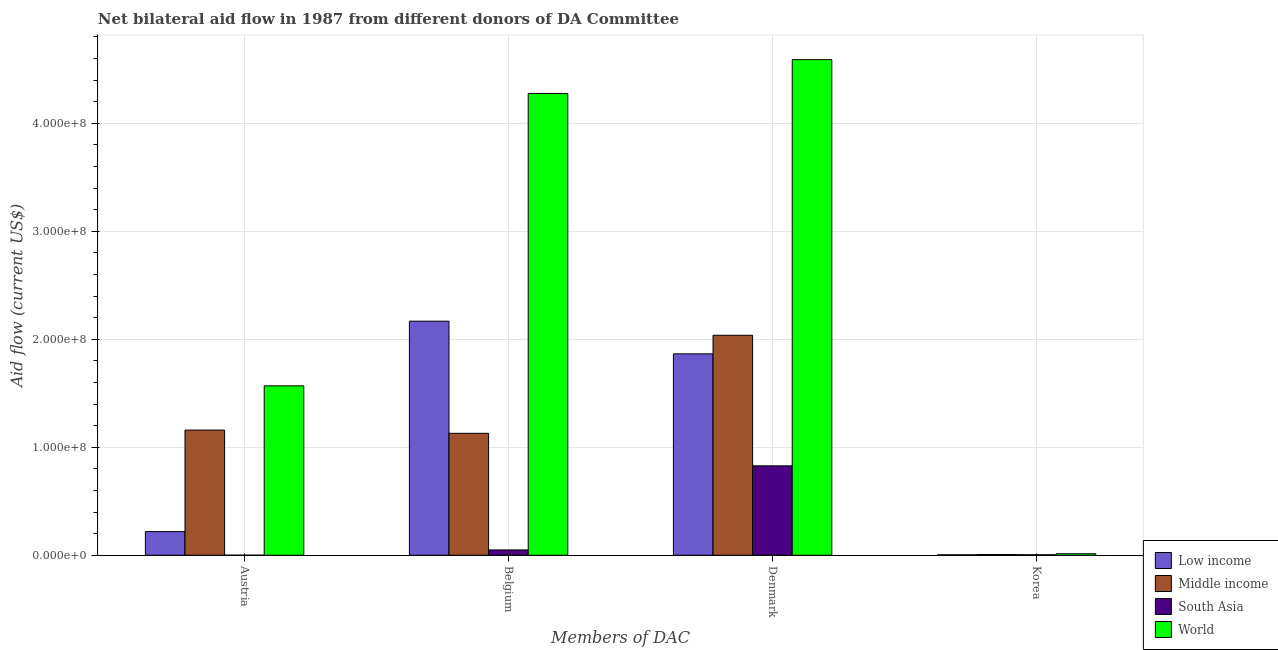How many different coloured bars are there?
Keep it short and to the point. 4. What is the label of the 4th group of bars from the left?
Keep it short and to the point. Korea. What is the amount of aid given by austria in World?
Give a very brief answer. 1.57e+08. Across all countries, what is the maximum amount of aid given by belgium?
Give a very brief answer. 4.28e+08. Across all countries, what is the minimum amount of aid given by austria?
Provide a succinct answer. 6.00e+04. In which country was the amount of aid given by korea maximum?
Keep it short and to the point. World. In which country was the amount of aid given by belgium minimum?
Provide a short and direct response. South Asia. What is the total amount of aid given by korea in the graph?
Ensure brevity in your answer.  2.94e+06. What is the difference between the amount of aid given by denmark in Middle income and that in World?
Your answer should be compact. -2.55e+08. What is the difference between the amount of aid given by korea in South Asia and the amount of aid given by belgium in Middle income?
Provide a succinct answer. -1.12e+08. What is the average amount of aid given by austria per country?
Keep it short and to the point. 7.37e+07. What is the difference between the amount of aid given by belgium and amount of aid given by austria in South Asia?
Your response must be concise. 4.87e+06. In how many countries, is the amount of aid given by korea greater than 380000000 US$?
Your answer should be compact. 0. What is the ratio of the amount of aid given by korea in Low income to that in World?
Offer a very short reply. 0.29. Is the amount of aid given by korea in Middle income less than that in South Asia?
Make the answer very short. No. Is the difference between the amount of aid given by belgium in Middle income and Low income greater than the difference between the amount of aid given by denmark in Middle income and Low income?
Ensure brevity in your answer.  No. What is the difference between the highest and the second highest amount of aid given by austria?
Offer a terse response. 4.10e+07. What is the difference between the highest and the lowest amount of aid given by belgium?
Offer a terse response. 4.23e+08. Is the sum of the amount of aid given by korea in Low income and South Asia greater than the maximum amount of aid given by denmark across all countries?
Make the answer very short. No. Is it the case that in every country, the sum of the amount of aid given by belgium and amount of aid given by korea is greater than the sum of amount of aid given by austria and amount of aid given by denmark?
Your response must be concise. No. Is it the case that in every country, the sum of the amount of aid given by austria and amount of aid given by belgium is greater than the amount of aid given by denmark?
Provide a short and direct response. No. Are all the bars in the graph horizontal?
Offer a very short reply. No. What is the difference between two consecutive major ticks on the Y-axis?
Offer a terse response. 1.00e+08. Does the graph contain any zero values?
Your answer should be compact. No. Does the graph contain grids?
Keep it short and to the point. Yes. How many legend labels are there?
Give a very brief answer. 4. What is the title of the graph?
Your response must be concise. Net bilateral aid flow in 1987 from different donors of DA Committee. What is the label or title of the X-axis?
Offer a terse response. Members of DAC. What is the Aid flow (current US$) of Low income in Austria?
Provide a succinct answer. 2.19e+07. What is the Aid flow (current US$) of Middle income in Austria?
Give a very brief answer. 1.16e+08. What is the Aid flow (current US$) of South Asia in Austria?
Keep it short and to the point. 6.00e+04. What is the Aid flow (current US$) of World in Austria?
Provide a succinct answer. 1.57e+08. What is the Aid flow (current US$) of Low income in Belgium?
Offer a very short reply. 2.17e+08. What is the Aid flow (current US$) of Middle income in Belgium?
Your answer should be very brief. 1.13e+08. What is the Aid flow (current US$) of South Asia in Belgium?
Make the answer very short. 4.93e+06. What is the Aid flow (current US$) in World in Belgium?
Your answer should be compact. 4.28e+08. What is the Aid flow (current US$) of Low income in Denmark?
Your answer should be very brief. 1.87e+08. What is the Aid flow (current US$) in Middle income in Denmark?
Your answer should be compact. 2.04e+08. What is the Aid flow (current US$) of South Asia in Denmark?
Provide a succinct answer. 8.28e+07. What is the Aid flow (current US$) in World in Denmark?
Make the answer very short. 4.59e+08. What is the Aid flow (current US$) of Middle income in Korea?
Offer a terse response. 6.70e+05. What is the Aid flow (current US$) of World in Korea?
Give a very brief answer. 1.40e+06. Across all Members of DAC, what is the maximum Aid flow (current US$) of Low income?
Offer a very short reply. 2.17e+08. Across all Members of DAC, what is the maximum Aid flow (current US$) of Middle income?
Your answer should be very brief. 2.04e+08. Across all Members of DAC, what is the maximum Aid flow (current US$) of South Asia?
Provide a succinct answer. 8.28e+07. Across all Members of DAC, what is the maximum Aid flow (current US$) of World?
Ensure brevity in your answer.  4.59e+08. Across all Members of DAC, what is the minimum Aid flow (current US$) in Low income?
Ensure brevity in your answer.  4.10e+05. Across all Members of DAC, what is the minimum Aid flow (current US$) in Middle income?
Ensure brevity in your answer.  6.70e+05. Across all Members of DAC, what is the minimum Aid flow (current US$) of South Asia?
Offer a terse response. 6.00e+04. Across all Members of DAC, what is the minimum Aid flow (current US$) in World?
Your response must be concise. 1.40e+06. What is the total Aid flow (current US$) in Low income in the graph?
Provide a succinct answer. 4.26e+08. What is the total Aid flow (current US$) in Middle income in the graph?
Provide a succinct answer. 4.33e+08. What is the total Aid flow (current US$) in South Asia in the graph?
Your response must be concise. 8.83e+07. What is the total Aid flow (current US$) of World in the graph?
Your answer should be compact. 1.05e+09. What is the difference between the Aid flow (current US$) in Low income in Austria and that in Belgium?
Offer a very short reply. -1.95e+08. What is the difference between the Aid flow (current US$) in Middle income in Austria and that in Belgium?
Keep it short and to the point. 3.01e+06. What is the difference between the Aid flow (current US$) in South Asia in Austria and that in Belgium?
Keep it short and to the point. -4.87e+06. What is the difference between the Aid flow (current US$) in World in Austria and that in Belgium?
Keep it short and to the point. -2.71e+08. What is the difference between the Aid flow (current US$) in Low income in Austria and that in Denmark?
Offer a terse response. -1.65e+08. What is the difference between the Aid flow (current US$) of Middle income in Austria and that in Denmark?
Offer a very short reply. -8.78e+07. What is the difference between the Aid flow (current US$) of South Asia in Austria and that in Denmark?
Your response must be concise. -8.28e+07. What is the difference between the Aid flow (current US$) of World in Austria and that in Denmark?
Your answer should be very brief. -3.02e+08. What is the difference between the Aid flow (current US$) of Low income in Austria and that in Korea?
Provide a succinct answer. 2.15e+07. What is the difference between the Aid flow (current US$) of Middle income in Austria and that in Korea?
Offer a terse response. 1.15e+08. What is the difference between the Aid flow (current US$) in South Asia in Austria and that in Korea?
Provide a short and direct response. -4.00e+05. What is the difference between the Aid flow (current US$) in World in Austria and that in Korea?
Offer a terse response. 1.56e+08. What is the difference between the Aid flow (current US$) in Low income in Belgium and that in Denmark?
Offer a terse response. 3.02e+07. What is the difference between the Aid flow (current US$) of Middle income in Belgium and that in Denmark?
Make the answer very short. -9.08e+07. What is the difference between the Aid flow (current US$) in South Asia in Belgium and that in Denmark?
Provide a short and direct response. -7.79e+07. What is the difference between the Aid flow (current US$) in World in Belgium and that in Denmark?
Offer a very short reply. -3.13e+07. What is the difference between the Aid flow (current US$) of Low income in Belgium and that in Korea?
Keep it short and to the point. 2.16e+08. What is the difference between the Aid flow (current US$) in Middle income in Belgium and that in Korea?
Your answer should be compact. 1.12e+08. What is the difference between the Aid flow (current US$) of South Asia in Belgium and that in Korea?
Your answer should be very brief. 4.47e+06. What is the difference between the Aid flow (current US$) in World in Belgium and that in Korea?
Keep it short and to the point. 4.26e+08. What is the difference between the Aid flow (current US$) in Low income in Denmark and that in Korea?
Keep it short and to the point. 1.86e+08. What is the difference between the Aid flow (current US$) of Middle income in Denmark and that in Korea?
Provide a succinct answer. 2.03e+08. What is the difference between the Aid flow (current US$) in South Asia in Denmark and that in Korea?
Provide a short and direct response. 8.24e+07. What is the difference between the Aid flow (current US$) in World in Denmark and that in Korea?
Keep it short and to the point. 4.58e+08. What is the difference between the Aid flow (current US$) of Low income in Austria and the Aid flow (current US$) of Middle income in Belgium?
Offer a terse response. -9.10e+07. What is the difference between the Aid flow (current US$) of Low income in Austria and the Aid flow (current US$) of South Asia in Belgium?
Offer a terse response. 1.70e+07. What is the difference between the Aid flow (current US$) in Low income in Austria and the Aid flow (current US$) in World in Belgium?
Your response must be concise. -4.06e+08. What is the difference between the Aid flow (current US$) of Middle income in Austria and the Aid flow (current US$) of South Asia in Belgium?
Your answer should be very brief. 1.11e+08. What is the difference between the Aid flow (current US$) of Middle income in Austria and the Aid flow (current US$) of World in Belgium?
Keep it short and to the point. -3.12e+08. What is the difference between the Aid flow (current US$) of South Asia in Austria and the Aid flow (current US$) of World in Belgium?
Your answer should be compact. -4.28e+08. What is the difference between the Aid flow (current US$) of Low income in Austria and the Aid flow (current US$) of Middle income in Denmark?
Your answer should be very brief. -1.82e+08. What is the difference between the Aid flow (current US$) of Low income in Austria and the Aid flow (current US$) of South Asia in Denmark?
Give a very brief answer. -6.09e+07. What is the difference between the Aid flow (current US$) of Low income in Austria and the Aid flow (current US$) of World in Denmark?
Ensure brevity in your answer.  -4.37e+08. What is the difference between the Aid flow (current US$) in Middle income in Austria and the Aid flow (current US$) in South Asia in Denmark?
Provide a succinct answer. 3.31e+07. What is the difference between the Aid flow (current US$) of Middle income in Austria and the Aid flow (current US$) of World in Denmark?
Ensure brevity in your answer.  -3.43e+08. What is the difference between the Aid flow (current US$) of South Asia in Austria and the Aid flow (current US$) of World in Denmark?
Ensure brevity in your answer.  -4.59e+08. What is the difference between the Aid flow (current US$) in Low income in Austria and the Aid flow (current US$) in Middle income in Korea?
Ensure brevity in your answer.  2.12e+07. What is the difference between the Aid flow (current US$) of Low income in Austria and the Aid flow (current US$) of South Asia in Korea?
Provide a succinct answer. 2.14e+07. What is the difference between the Aid flow (current US$) in Low income in Austria and the Aid flow (current US$) in World in Korea?
Make the answer very short. 2.05e+07. What is the difference between the Aid flow (current US$) of Middle income in Austria and the Aid flow (current US$) of South Asia in Korea?
Provide a short and direct response. 1.15e+08. What is the difference between the Aid flow (current US$) in Middle income in Austria and the Aid flow (current US$) in World in Korea?
Offer a terse response. 1.15e+08. What is the difference between the Aid flow (current US$) of South Asia in Austria and the Aid flow (current US$) of World in Korea?
Your response must be concise. -1.34e+06. What is the difference between the Aid flow (current US$) of Low income in Belgium and the Aid flow (current US$) of Middle income in Denmark?
Offer a very short reply. 1.30e+07. What is the difference between the Aid flow (current US$) in Low income in Belgium and the Aid flow (current US$) in South Asia in Denmark?
Your answer should be compact. 1.34e+08. What is the difference between the Aid flow (current US$) in Low income in Belgium and the Aid flow (current US$) in World in Denmark?
Offer a terse response. -2.42e+08. What is the difference between the Aid flow (current US$) of Middle income in Belgium and the Aid flow (current US$) of South Asia in Denmark?
Make the answer very short. 3.01e+07. What is the difference between the Aid flow (current US$) of Middle income in Belgium and the Aid flow (current US$) of World in Denmark?
Give a very brief answer. -3.46e+08. What is the difference between the Aid flow (current US$) of South Asia in Belgium and the Aid flow (current US$) of World in Denmark?
Offer a terse response. -4.54e+08. What is the difference between the Aid flow (current US$) in Low income in Belgium and the Aid flow (current US$) in Middle income in Korea?
Offer a terse response. 2.16e+08. What is the difference between the Aid flow (current US$) of Low income in Belgium and the Aid flow (current US$) of South Asia in Korea?
Offer a terse response. 2.16e+08. What is the difference between the Aid flow (current US$) of Low income in Belgium and the Aid flow (current US$) of World in Korea?
Provide a short and direct response. 2.15e+08. What is the difference between the Aid flow (current US$) in Middle income in Belgium and the Aid flow (current US$) in South Asia in Korea?
Your response must be concise. 1.12e+08. What is the difference between the Aid flow (current US$) in Middle income in Belgium and the Aid flow (current US$) in World in Korea?
Your answer should be very brief. 1.12e+08. What is the difference between the Aid flow (current US$) of South Asia in Belgium and the Aid flow (current US$) of World in Korea?
Provide a succinct answer. 3.53e+06. What is the difference between the Aid flow (current US$) in Low income in Denmark and the Aid flow (current US$) in Middle income in Korea?
Provide a succinct answer. 1.86e+08. What is the difference between the Aid flow (current US$) in Low income in Denmark and the Aid flow (current US$) in South Asia in Korea?
Your response must be concise. 1.86e+08. What is the difference between the Aid flow (current US$) of Low income in Denmark and the Aid flow (current US$) of World in Korea?
Provide a short and direct response. 1.85e+08. What is the difference between the Aid flow (current US$) of Middle income in Denmark and the Aid flow (current US$) of South Asia in Korea?
Keep it short and to the point. 2.03e+08. What is the difference between the Aid flow (current US$) of Middle income in Denmark and the Aid flow (current US$) of World in Korea?
Make the answer very short. 2.02e+08. What is the difference between the Aid flow (current US$) in South Asia in Denmark and the Aid flow (current US$) in World in Korea?
Your response must be concise. 8.14e+07. What is the average Aid flow (current US$) of Low income per Members of DAC?
Make the answer very short. 1.06e+08. What is the average Aid flow (current US$) in Middle income per Members of DAC?
Your answer should be very brief. 1.08e+08. What is the average Aid flow (current US$) of South Asia per Members of DAC?
Make the answer very short. 2.21e+07. What is the average Aid flow (current US$) of World per Members of DAC?
Provide a short and direct response. 2.61e+08. What is the difference between the Aid flow (current US$) of Low income and Aid flow (current US$) of Middle income in Austria?
Offer a very short reply. -9.40e+07. What is the difference between the Aid flow (current US$) in Low income and Aid flow (current US$) in South Asia in Austria?
Offer a very short reply. 2.18e+07. What is the difference between the Aid flow (current US$) of Low income and Aid flow (current US$) of World in Austria?
Your answer should be compact. -1.35e+08. What is the difference between the Aid flow (current US$) in Middle income and Aid flow (current US$) in South Asia in Austria?
Provide a succinct answer. 1.16e+08. What is the difference between the Aid flow (current US$) of Middle income and Aid flow (current US$) of World in Austria?
Your response must be concise. -4.10e+07. What is the difference between the Aid flow (current US$) of South Asia and Aid flow (current US$) of World in Austria?
Provide a succinct answer. -1.57e+08. What is the difference between the Aid flow (current US$) in Low income and Aid flow (current US$) in Middle income in Belgium?
Your answer should be compact. 1.04e+08. What is the difference between the Aid flow (current US$) of Low income and Aid flow (current US$) of South Asia in Belgium?
Provide a succinct answer. 2.12e+08. What is the difference between the Aid flow (current US$) of Low income and Aid flow (current US$) of World in Belgium?
Your answer should be compact. -2.11e+08. What is the difference between the Aid flow (current US$) of Middle income and Aid flow (current US$) of South Asia in Belgium?
Offer a terse response. 1.08e+08. What is the difference between the Aid flow (current US$) in Middle income and Aid flow (current US$) in World in Belgium?
Your answer should be very brief. -3.15e+08. What is the difference between the Aid flow (current US$) in South Asia and Aid flow (current US$) in World in Belgium?
Ensure brevity in your answer.  -4.23e+08. What is the difference between the Aid flow (current US$) in Low income and Aid flow (current US$) in Middle income in Denmark?
Offer a terse response. -1.72e+07. What is the difference between the Aid flow (current US$) of Low income and Aid flow (current US$) of South Asia in Denmark?
Provide a succinct answer. 1.04e+08. What is the difference between the Aid flow (current US$) in Low income and Aid flow (current US$) in World in Denmark?
Offer a terse response. -2.72e+08. What is the difference between the Aid flow (current US$) of Middle income and Aid flow (current US$) of South Asia in Denmark?
Give a very brief answer. 1.21e+08. What is the difference between the Aid flow (current US$) of Middle income and Aid flow (current US$) of World in Denmark?
Provide a short and direct response. -2.55e+08. What is the difference between the Aid flow (current US$) of South Asia and Aid flow (current US$) of World in Denmark?
Keep it short and to the point. -3.76e+08. What is the difference between the Aid flow (current US$) of Low income and Aid flow (current US$) of Middle income in Korea?
Keep it short and to the point. -2.60e+05. What is the difference between the Aid flow (current US$) of Low income and Aid flow (current US$) of South Asia in Korea?
Ensure brevity in your answer.  -5.00e+04. What is the difference between the Aid flow (current US$) in Low income and Aid flow (current US$) in World in Korea?
Offer a terse response. -9.90e+05. What is the difference between the Aid flow (current US$) in Middle income and Aid flow (current US$) in South Asia in Korea?
Ensure brevity in your answer.  2.10e+05. What is the difference between the Aid flow (current US$) in Middle income and Aid flow (current US$) in World in Korea?
Your answer should be compact. -7.30e+05. What is the difference between the Aid flow (current US$) in South Asia and Aid flow (current US$) in World in Korea?
Give a very brief answer. -9.40e+05. What is the ratio of the Aid flow (current US$) of Low income in Austria to that in Belgium?
Provide a short and direct response. 0.1. What is the ratio of the Aid flow (current US$) in Middle income in Austria to that in Belgium?
Provide a short and direct response. 1.03. What is the ratio of the Aid flow (current US$) of South Asia in Austria to that in Belgium?
Your response must be concise. 0.01. What is the ratio of the Aid flow (current US$) in World in Austria to that in Belgium?
Your response must be concise. 0.37. What is the ratio of the Aid flow (current US$) in Low income in Austria to that in Denmark?
Give a very brief answer. 0.12. What is the ratio of the Aid flow (current US$) of Middle income in Austria to that in Denmark?
Provide a short and direct response. 0.57. What is the ratio of the Aid flow (current US$) in South Asia in Austria to that in Denmark?
Provide a succinct answer. 0. What is the ratio of the Aid flow (current US$) in World in Austria to that in Denmark?
Make the answer very short. 0.34. What is the ratio of the Aid flow (current US$) of Low income in Austria to that in Korea?
Your answer should be compact. 53.44. What is the ratio of the Aid flow (current US$) in Middle income in Austria to that in Korea?
Offer a terse response. 173.06. What is the ratio of the Aid flow (current US$) in South Asia in Austria to that in Korea?
Offer a very short reply. 0.13. What is the ratio of the Aid flow (current US$) of World in Austria to that in Korea?
Your response must be concise. 112.07. What is the ratio of the Aid flow (current US$) of Low income in Belgium to that in Denmark?
Your answer should be compact. 1.16. What is the ratio of the Aid flow (current US$) of Middle income in Belgium to that in Denmark?
Offer a very short reply. 0.55. What is the ratio of the Aid flow (current US$) in South Asia in Belgium to that in Denmark?
Make the answer very short. 0.06. What is the ratio of the Aid flow (current US$) in World in Belgium to that in Denmark?
Offer a very short reply. 0.93. What is the ratio of the Aid flow (current US$) in Low income in Belgium to that in Korea?
Make the answer very short. 528.76. What is the ratio of the Aid flow (current US$) of Middle income in Belgium to that in Korea?
Your response must be concise. 168.57. What is the ratio of the Aid flow (current US$) of South Asia in Belgium to that in Korea?
Make the answer very short. 10.72. What is the ratio of the Aid flow (current US$) of World in Belgium to that in Korea?
Ensure brevity in your answer.  305.5. What is the ratio of the Aid flow (current US$) in Low income in Denmark to that in Korea?
Provide a short and direct response. 455. What is the ratio of the Aid flow (current US$) in Middle income in Denmark to that in Korea?
Your answer should be compact. 304.12. What is the ratio of the Aid flow (current US$) in South Asia in Denmark to that in Korea?
Offer a very short reply. 180.04. What is the ratio of the Aid flow (current US$) of World in Denmark to that in Korea?
Offer a very short reply. 327.86. What is the difference between the highest and the second highest Aid flow (current US$) of Low income?
Keep it short and to the point. 3.02e+07. What is the difference between the highest and the second highest Aid flow (current US$) in Middle income?
Offer a terse response. 8.78e+07. What is the difference between the highest and the second highest Aid flow (current US$) in South Asia?
Provide a succinct answer. 7.79e+07. What is the difference between the highest and the second highest Aid flow (current US$) in World?
Provide a succinct answer. 3.13e+07. What is the difference between the highest and the lowest Aid flow (current US$) in Low income?
Your answer should be very brief. 2.16e+08. What is the difference between the highest and the lowest Aid flow (current US$) in Middle income?
Give a very brief answer. 2.03e+08. What is the difference between the highest and the lowest Aid flow (current US$) in South Asia?
Your answer should be very brief. 8.28e+07. What is the difference between the highest and the lowest Aid flow (current US$) in World?
Ensure brevity in your answer.  4.58e+08. 